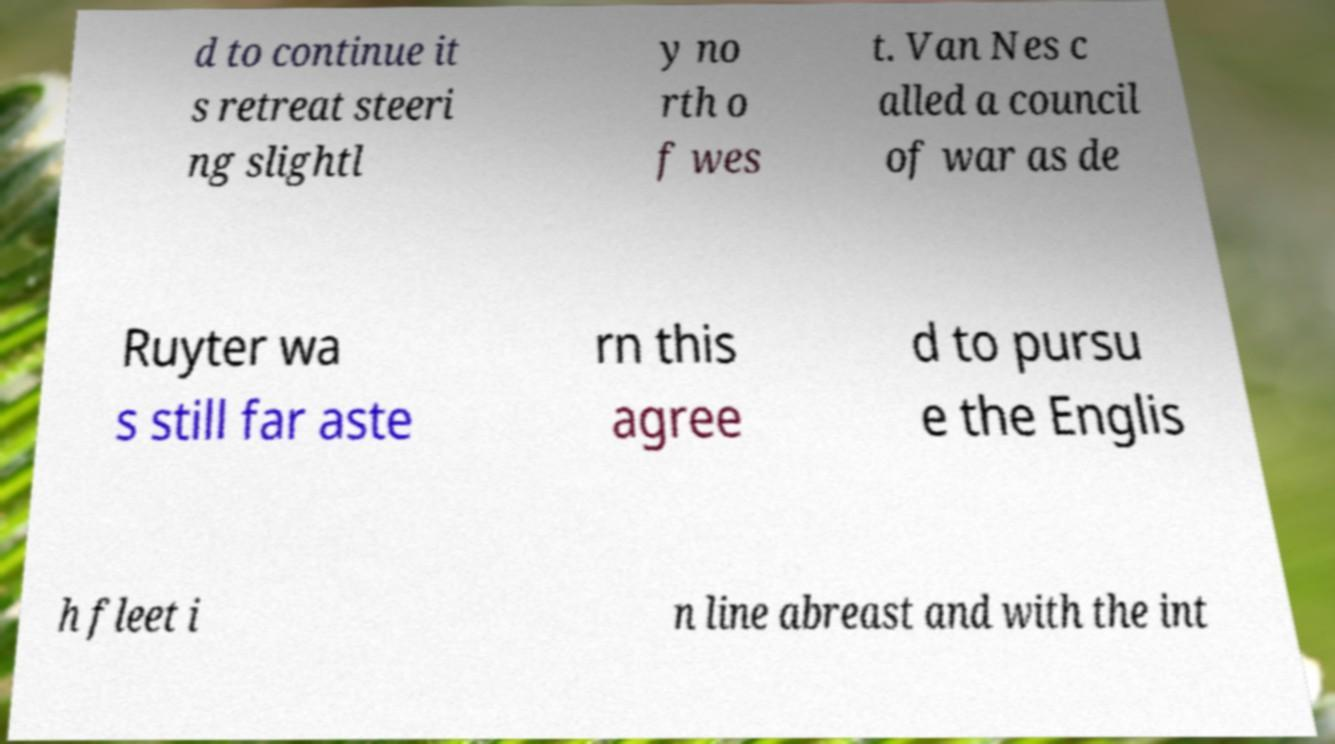For documentation purposes, I need the text within this image transcribed. Could you provide that? d to continue it s retreat steeri ng slightl y no rth o f wes t. Van Nes c alled a council of war as de Ruyter wa s still far aste rn this agree d to pursu e the Englis h fleet i n line abreast and with the int 